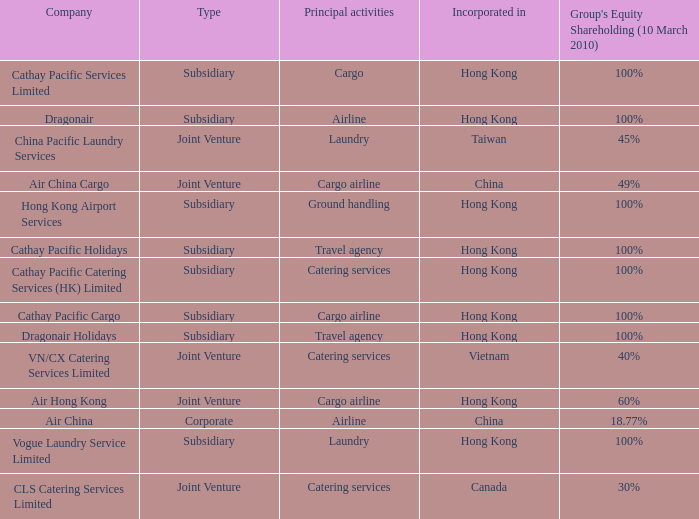Could you parse the entire table as a dict? {'header': ['Company', 'Type', 'Principal activities', 'Incorporated in', "Group's Equity Shareholding (10 March 2010)"], 'rows': [['Cathay Pacific Services Limited', 'Subsidiary', 'Cargo', 'Hong Kong', '100%'], ['Dragonair', 'Subsidiary', 'Airline', 'Hong Kong', '100%'], ['China Pacific Laundry Services', 'Joint Venture', 'Laundry', 'Taiwan', '45%'], ['Air China Cargo', 'Joint Venture', 'Cargo airline', 'China', '49%'], ['Hong Kong Airport Services', 'Subsidiary', 'Ground handling', 'Hong Kong', '100%'], ['Cathay Pacific Holidays', 'Subsidiary', 'Travel agency', 'Hong Kong', '100%'], ['Cathay Pacific Catering Services (HK) Limited', 'Subsidiary', 'Catering services', 'Hong Kong', '100%'], ['Cathay Pacific Cargo', 'Subsidiary', 'Cargo airline', 'Hong Kong', '100%'], ['Dragonair Holidays', 'Subsidiary', 'Travel agency', 'Hong Kong', '100%'], ['VN/CX Catering Services Limited', 'Joint Venture', 'Catering services', 'Vietnam', '40%'], ['Air Hong Kong', 'Joint Venture', 'Cargo airline', 'Hong Kong', '60%'], ['Air China', 'Corporate', 'Airline', 'China', '18.77%'], ['Vogue Laundry Service Limited', 'Subsidiary', 'Laundry', 'Hong Kong', '100%'], ['CLS Catering Services Limited', 'Joint Venture', 'Catering services', 'Canada', '30%']]} What is the name of the company that has a Group's equity shareholding percentage, as of March 10th, 2010, of 100%, as well as a Principal activity of Airline? Dragonair. 